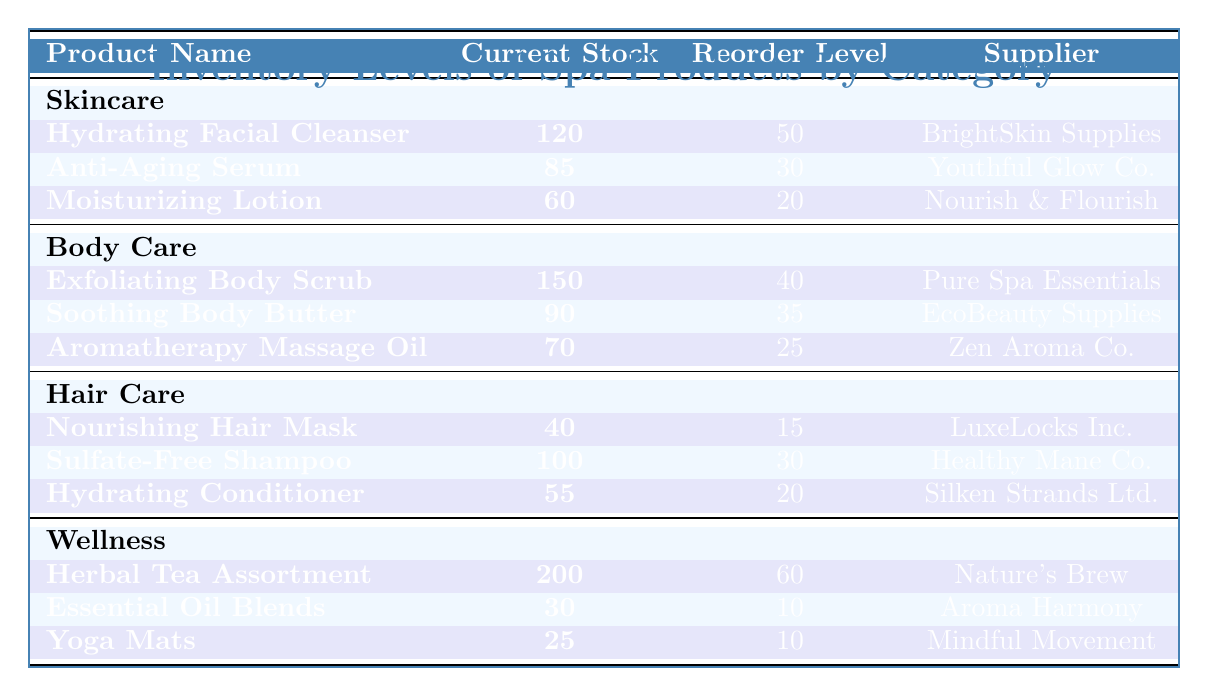What is the current stock level of the "Exfoliating Body Scrub"? The table shows the "Exfoliating Body Scrub" under the Body Care category, with a current stock listed as **150**.
Answer: 150 Which supplier provides the "Hydrating Facial Cleanser"? By checking the row for the "Hydrating Facial Cleanser" in the Skincare category, the supplier listed is **BrightSkin Supplies**.
Answer: BrightSkin Supplies Does the "Essential Oil Blends" require replenishment? The reorder level for "Essential Oil Blends" is **10**, and the current stock is **30**. Since 30 is above 10, it does not require replenishment.
Answer: No What is the total current stock for all products in the Hair Care category? The current stock for Hair Care products is calculated as follows: Nourishing Hair Mask (40) + Sulfate-Free Shampoo (100) + Hydrating Conditioner (55) = 40 + 100 + 55 = **195**.
Answer: 195 Are there any products in the Wellness category that are at or below their reorder level? The "Essential Oil Blends" (current stock 30) is above its reorder level of 10, and "Yoga Mats" (current stock 25) is also above its reorder level of 10. Thus, none are at or below their reorder levels.
Answer: No What is the difference between the current stock of "Hydrating Facial Cleanser" and "Moisturizing Lotion"? The "Hydrating Facial Cleanser" has a current stock of **120**, and the "Moisturizing Lotion" has **60**. The difference is calculated as 120 - 60 = **60**.
Answer: 60 Which category has the highest overall current stock? The current stocks by category are: Skincare (120 + 85 + 60 = 265), Body Care (150 + 90 + 70 = 310), Hair Care (40 + 100 + 55 = 195), and Wellness (200 + 30 + 25 = 255). The highest is Body Care with **310**.
Answer: Body Care How many products in the spa inventory have a current stock of less than 60? The products are: Nourishing Hair Mask (40), Essential Oil Blends (30), and Yoga Mats (25). There are **3** products with a current stock of less than 60.
Answer: 3 What is the average reorder level across all categories? The reorder levels are: Skincare (50, 30, 20), Body Care (40, 35, 25), Hair Care (15, 30, 20), and Wellness (60, 10, 10). First sum these: 50 + 30 + 20 + 40 + 35 + 25 + 15 + 30 + 20 + 60 + 10 + 10 =  340. There are 12 values, so 340 / 12 = **28.33**.
Answer: 28.33 Which product in the Body Care category has the lowest current stock? From the Body Care items, we have 150 (Exfoliating Body Scrub), 90 (Soothing Body Butter), and 70 (Aromatherapy Massage Oil). The lowest current stock is from **Aromatherapy Massage Oil** with 70.
Answer: Aromatherapy Massage Oil 